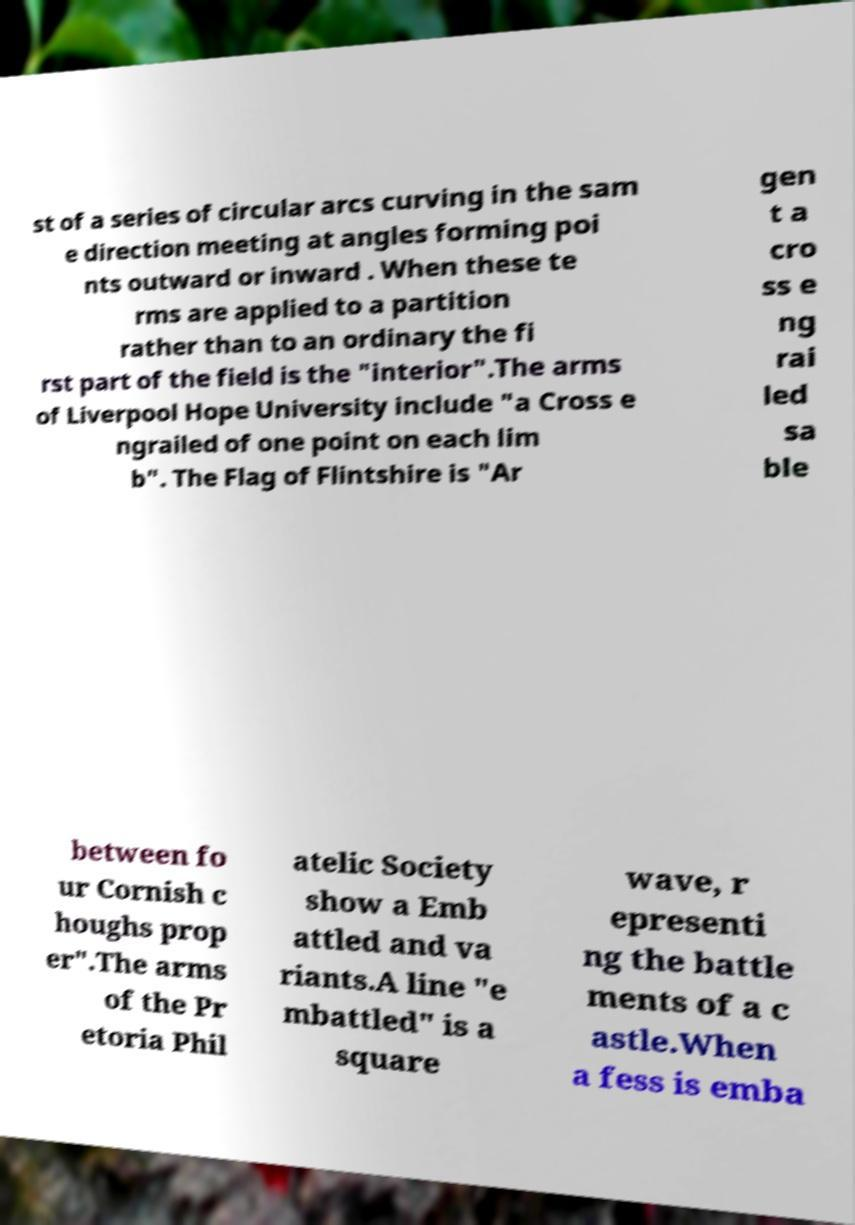Can you read and provide the text displayed in the image?This photo seems to have some interesting text. Can you extract and type it out for me? st of a series of circular arcs curving in the sam e direction meeting at angles forming poi nts outward or inward . When these te rms are applied to a partition rather than to an ordinary the fi rst part of the field is the "interior".The arms of Liverpool Hope University include "a Cross e ngrailed of one point on each lim b". The Flag of Flintshire is "Ar gen t a cro ss e ng rai led sa ble between fo ur Cornish c houghs prop er".The arms of the Pr etoria Phil atelic Society show a Emb attled and va riants.A line "e mbattled" is a square wave, r epresenti ng the battle ments of a c astle.When a fess is emba 